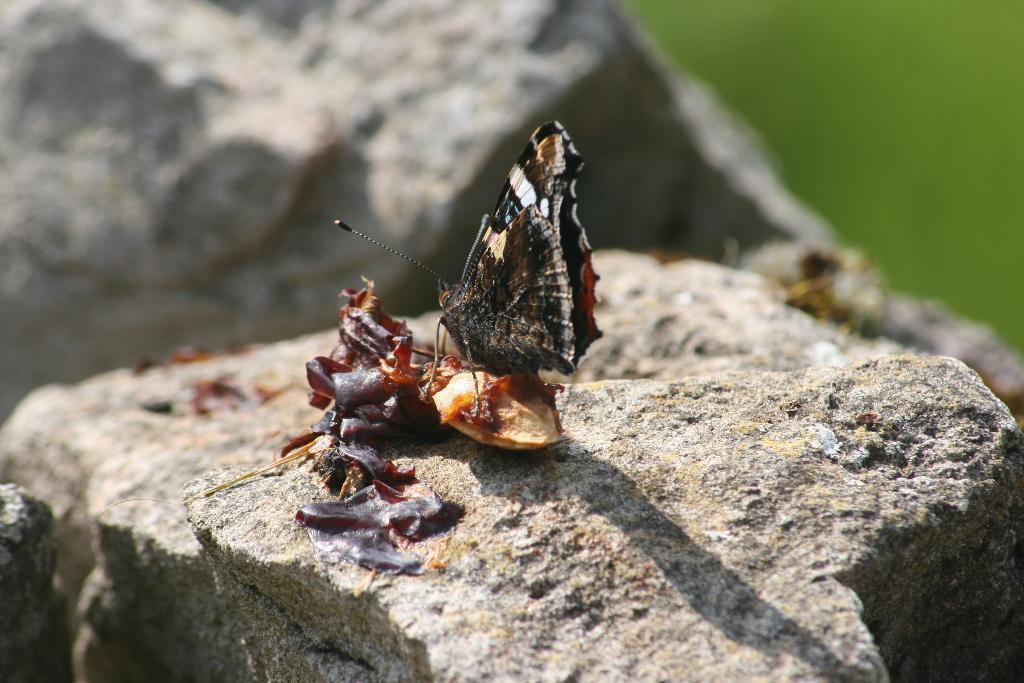Please provide a concise description of this image. In this image we can see an insect on the stone surface. 